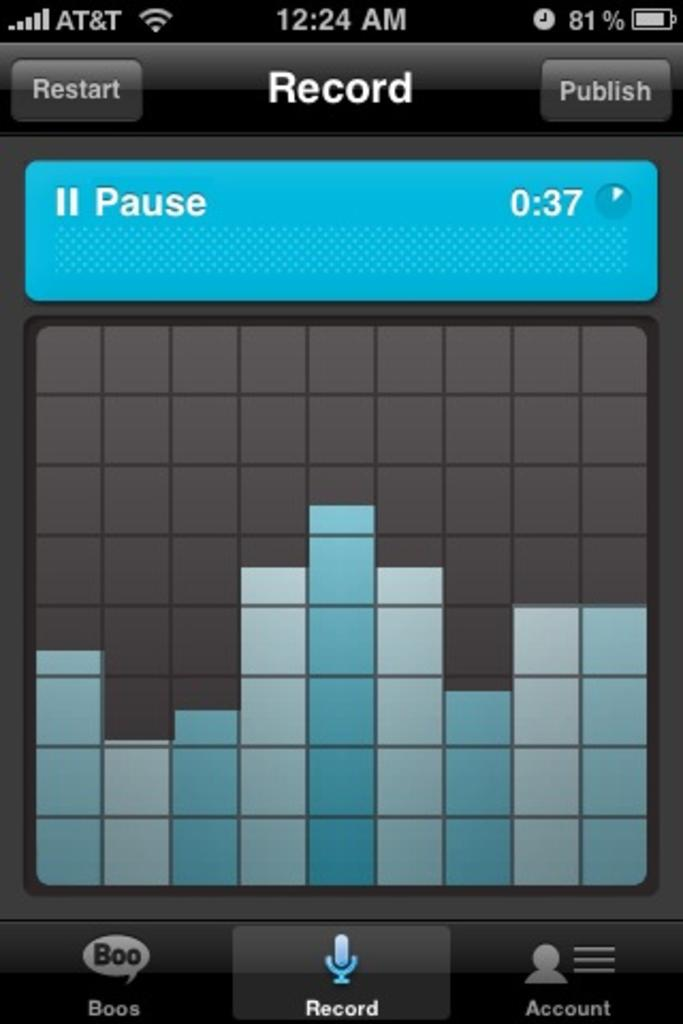<image>
Render a clear and concise summary of the photo. a screenshot of an iphone screen that says 'at&t' at the top left 